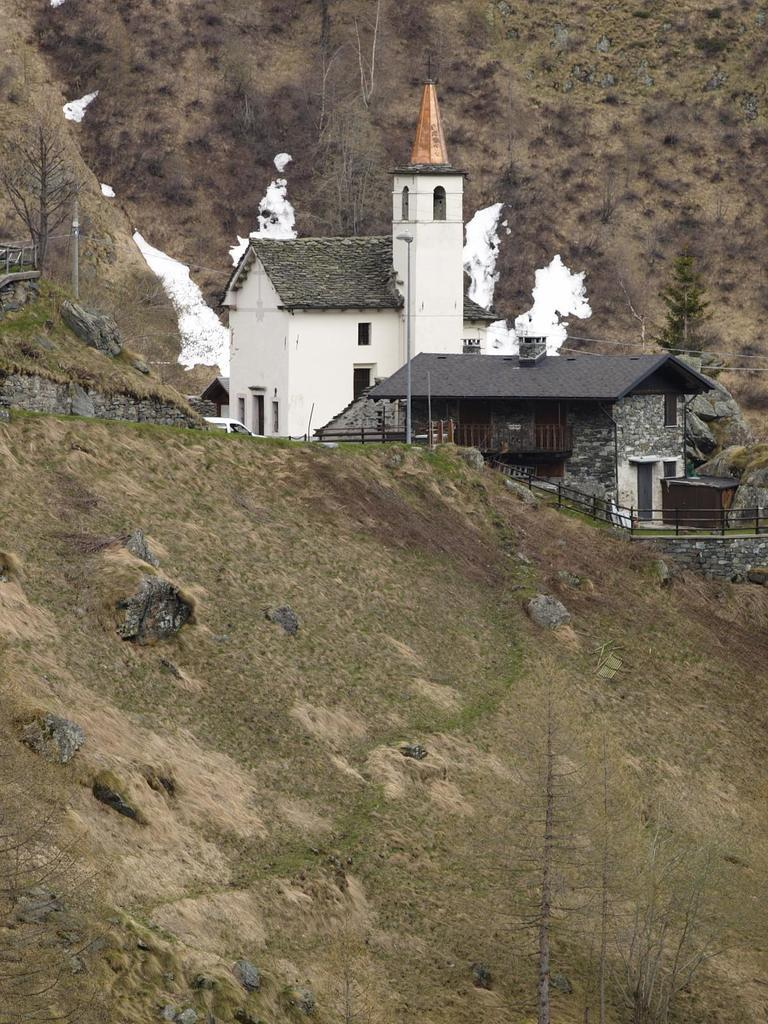What type of structures can be seen in the image? There are houses in the image. What is separating the houses or dividing the space in the image? There is a fence in the image. What type of vegetation is present in the image? Grass is present in the image. What other natural elements can be seen in the image? There are trees in the image. What type of beef is being cooked on the stove in the image? There is no beef or stove present in the image; it features houses, a fence, grass, and trees. 